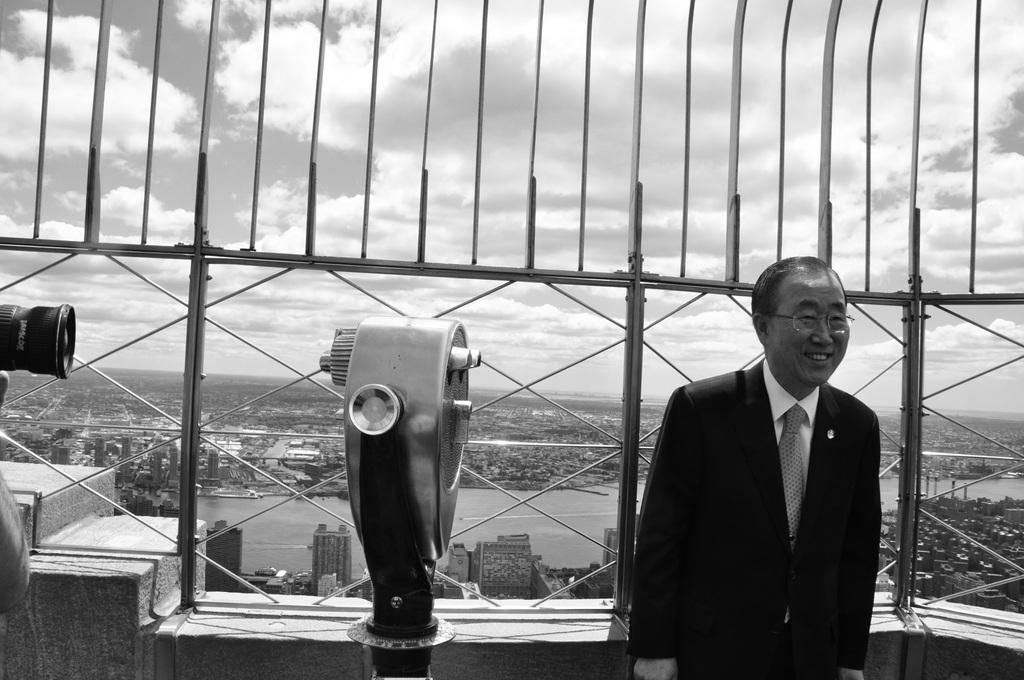Who is present in the image? There is a man in the image. What object can be seen in the man's hand? There is a camera in the image. What is the man standing near? There is railing in the image. What can be seen in the background of the image? There are buildings, water, and the sky visible in the background of the image. What is the condition of the sky in the image? Clouds are present in the sky. What type of soda is the man drinking in the image? There is no soda present in the image; the man is holding a camera. How many clams can be seen on the railing in the image? There are no clams present in the image; the railing is a separate object from the man and camera. 